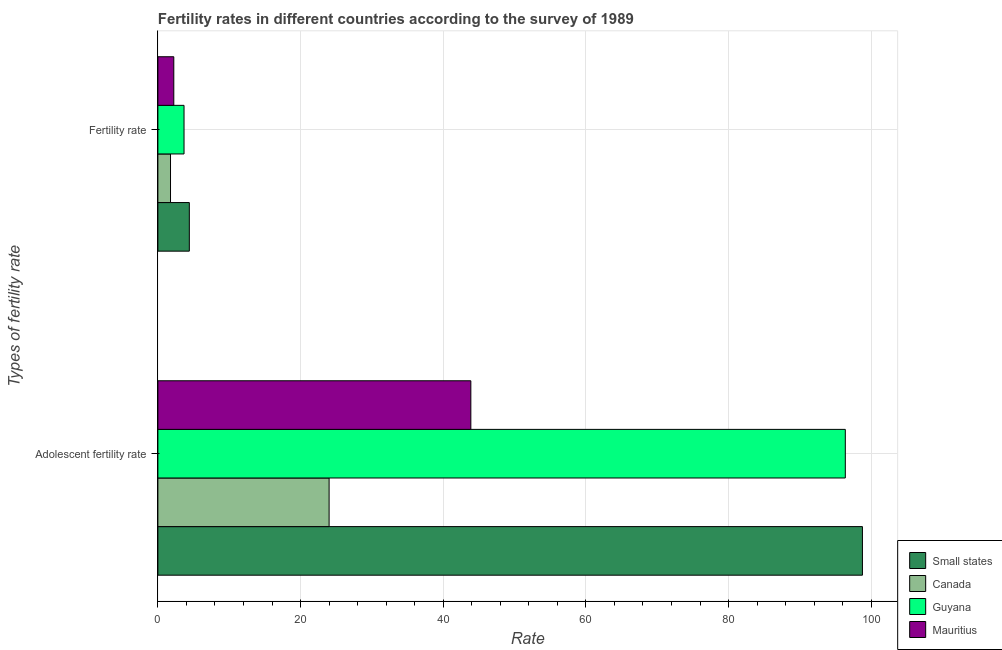How many groups of bars are there?
Give a very brief answer. 2. How many bars are there on the 2nd tick from the top?
Provide a short and direct response. 4. What is the label of the 2nd group of bars from the top?
Keep it short and to the point. Adolescent fertility rate. What is the fertility rate in Mauritius?
Make the answer very short. 2.23. Across all countries, what is the maximum adolescent fertility rate?
Offer a very short reply. 98.77. Across all countries, what is the minimum adolescent fertility rate?
Your answer should be compact. 24. In which country was the adolescent fertility rate maximum?
Your response must be concise. Small states. What is the total fertility rate in the graph?
Provide a short and direct response. 12.07. What is the difference between the fertility rate in Small states and that in Guyana?
Offer a very short reply. 0.74. What is the difference between the fertility rate in Guyana and the adolescent fertility rate in Canada?
Your answer should be compact. -20.34. What is the average fertility rate per country?
Your response must be concise. 3.02. What is the difference between the adolescent fertility rate and fertility rate in Guyana?
Offer a very short reply. 92.7. In how many countries, is the fertility rate greater than 28 ?
Make the answer very short. 0. What is the ratio of the fertility rate in Mauritius to that in Canada?
Your answer should be very brief. 1.26. What does the 4th bar from the top in Adolescent fertility rate represents?
Offer a terse response. Small states. What does the 3rd bar from the bottom in Fertility rate represents?
Your response must be concise. Guyana. How many countries are there in the graph?
Offer a terse response. 4. What is the difference between two consecutive major ticks on the X-axis?
Make the answer very short. 20. Are the values on the major ticks of X-axis written in scientific E-notation?
Offer a very short reply. No. Does the graph contain any zero values?
Provide a succinct answer. No. Where does the legend appear in the graph?
Your answer should be compact. Bottom right. What is the title of the graph?
Provide a short and direct response. Fertility rates in different countries according to the survey of 1989. Does "High income: nonOECD" appear as one of the legend labels in the graph?
Offer a terse response. No. What is the label or title of the X-axis?
Offer a terse response. Rate. What is the label or title of the Y-axis?
Ensure brevity in your answer.  Types of fertility rate. What is the Rate of Small states in Adolescent fertility rate?
Keep it short and to the point. 98.77. What is the Rate in Canada in Adolescent fertility rate?
Offer a terse response. 24. What is the Rate in Guyana in Adolescent fertility rate?
Keep it short and to the point. 96.37. What is the Rate of Mauritius in Adolescent fertility rate?
Provide a succinct answer. 43.87. What is the Rate in Small states in Fertility rate?
Offer a terse response. 4.41. What is the Rate in Canada in Fertility rate?
Offer a terse response. 1.77. What is the Rate in Guyana in Fertility rate?
Offer a terse response. 3.67. What is the Rate in Mauritius in Fertility rate?
Keep it short and to the point. 2.23. Across all Types of fertility rate, what is the maximum Rate of Small states?
Your answer should be compact. 98.77. Across all Types of fertility rate, what is the maximum Rate of Canada?
Provide a short and direct response. 24. Across all Types of fertility rate, what is the maximum Rate of Guyana?
Offer a terse response. 96.37. Across all Types of fertility rate, what is the maximum Rate in Mauritius?
Keep it short and to the point. 43.87. Across all Types of fertility rate, what is the minimum Rate of Small states?
Offer a very short reply. 4.41. Across all Types of fertility rate, what is the minimum Rate in Canada?
Make the answer very short. 1.77. Across all Types of fertility rate, what is the minimum Rate of Guyana?
Offer a very short reply. 3.67. Across all Types of fertility rate, what is the minimum Rate in Mauritius?
Your answer should be very brief. 2.23. What is the total Rate of Small states in the graph?
Your answer should be compact. 103.17. What is the total Rate of Canada in the graph?
Your answer should be very brief. 25.77. What is the total Rate of Guyana in the graph?
Give a very brief answer. 100.03. What is the total Rate in Mauritius in the graph?
Offer a terse response. 46.1. What is the difference between the Rate of Small states in Adolescent fertility rate and that in Fertility rate?
Ensure brevity in your answer.  94.36. What is the difference between the Rate in Canada in Adolescent fertility rate and that in Fertility rate?
Your response must be concise. 22.23. What is the difference between the Rate in Guyana in Adolescent fertility rate and that in Fertility rate?
Offer a terse response. 92.7. What is the difference between the Rate in Mauritius in Adolescent fertility rate and that in Fertility rate?
Make the answer very short. 41.64. What is the difference between the Rate of Small states in Adolescent fertility rate and the Rate of Canada in Fertility rate?
Your response must be concise. 97. What is the difference between the Rate of Small states in Adolescent fertility rate and the Rate of Guyana in Fertility rate?
Offer a terse response. 95.1. What is the difference between the Rate of Small states in Adolescent fertility rate and the Rate of Mauritius in Fertility rate?
Your answer should be very brief. 96.54. What is the difference between the Rate of Canada in Adolescent fertility rate and the Rate of Guyana in Fertility rate?
Keep it short and to the point. 20.34. What is the difference between the Rate in Canada in Adolescent fertility rate and the Rate in Mauritius in Fertility rate?
Ensure brevity in your answer.  21.77. What is the difference between the Rate in Guyana in Adolescent fertility rate and the Rate in Mauritius in Fertility rate?
Make the answer very short. 94.14. What is the average Rate of Small states per Types of fertility rate?
Make the answer very short. 51.59. What is the average Rate of Canada per Types of fertility rate?
Offer a terse response. 12.89. What is the average Rate of Guyana per Types of fertility rate?
Your answer should be very brief. 50.02. What is the average Rate of Mauritius per Types of fertility rate?
Your answer should be compact. 23.05. What is the difference between the Rate in Small states and Rate in Canada in Adolescent fertility rate?
Give a very brief answer. 74.76. What is the difference between the Rate in Small states and Rate in Guyana in Adolescent fertility rate?
Give a very brief answer. 2.4. What is the difference between the Rate of Small states and Rate of Mauritius in Adolescent fertility rate?
Keep it short and to the point. 54.9. What is the difference between the Rate of Canada and Rate of Guyana in Adolescent fertility rate?
Give a very brief answer. -72.36. What is the difference between the Rate of Canada and Rate of Mauritius in Adolescent fertility rate?
Your answer should be compact. -19.87. What is the difference between the Rate of Guyana and Rate of Mauritius in Adolescent fertility rate?
Your answer should be compact. 52.5. What is the difference between the Rate of Small states and Rate of Canada in Fertility rate?
Offer a very short reply. 2.64. What is the difference between the Rate of Small states and Rate of Guyana in Fertility rate?
Offer a terse response. 0.74. What is the difference between the Rate in Small states and Rate in Mauritius in Fertility rate?
Your answer should be compact. 2.18. What is the difference between the Rate in Canada and Rate in Guyana in Fertility rate?
Keep it short and to the point. -1.9. What is the difference between the Rate in Canada and Rate in Mauritius in Fertility rate?
Ensure brevity in your answer.  -0.46. What is the difference between the Rate of Guyana and Rate of Mauritius in Fertility rate?
Offer a terse response. 1.44. What is the ratio of the Rate of Small states in Adolescent fertility rate to that in Fertility rate?
Provide a short and direct response. 22.41. What is the ratio of the Rate in Canada in Adolescent fertility rate to that in Fertility rate?
Your response must be concise. 13.56. What is the ratio of the Rate of Guyana in Adolescent fertility rate to that in Fertility rate?
Provide a short and direct response. 26.29. What is the ratio of the Rate in Mauritius in Adolescent fertility rate to that in Fertility rate?
Your answer should be compact. 19.67. What is the difference between the highest and the second highest Rate in Small states?
Provide a succinct answer. 94.36. What is the difference between the highest and the second highest Rate of Canada?
Offer a terse response. 22.23. What is the difference between the highest and the second highest Rate in Guyana?
Ensure brevity in your answer.  92.7. What is the difference between the highest and the second highest Rate in Mauritius?
Ensure brevity in your answer.  41.64. What is the difference between the highest and the lowest Rate of Small states?
Your answer should be compact. 94.36. What is the difference between the highest and the lowest Rate in Canada?
Offer a very short reply. 22.23. What is the difference between the highest and the lowest Rate of Guyana?
Give a very brief answer. 92.7. What is the difference between the highest and the lowest Rate in Mauritius?
Give a very brief answer. 41.64. 